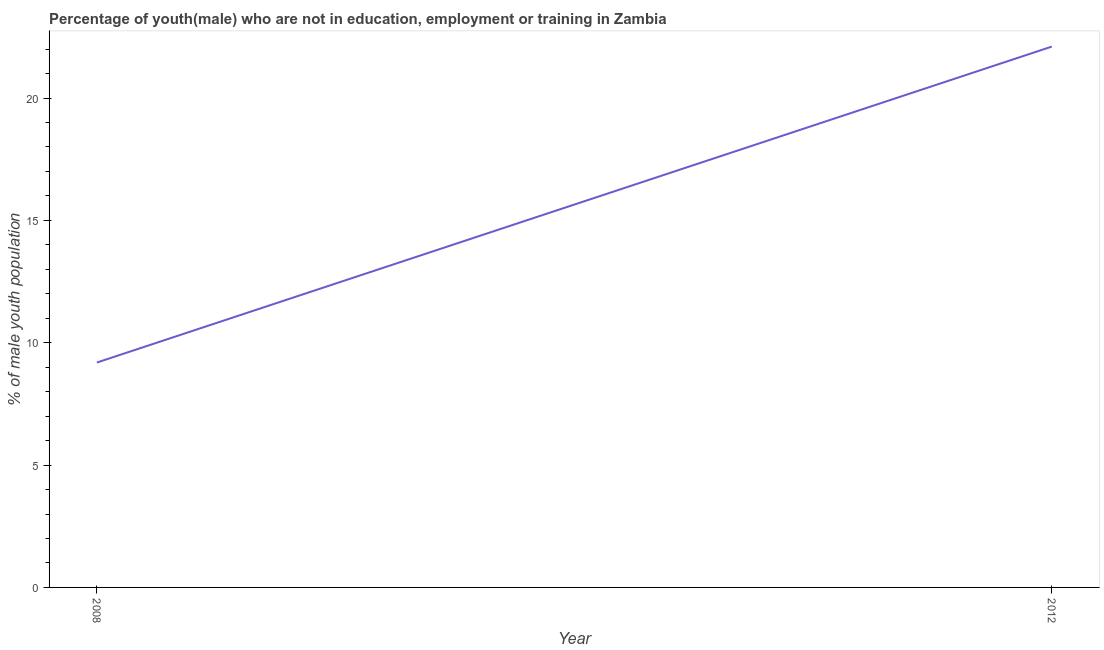What is the unemployed male youth population in 2012?
Make the answer very short. 22.1. Across all years, what is the maximum unemployed male youth population?
Provide a short and direct response. 22.1. Across all years, what is the minimum unemployed male youth population?
Your response must be concise. 9.19. What is the sum of the unemployed male youth population?
Your response must be concise. 31.29. What is the difference between the unemployed male youth population in 2008 and 2012?
Offer a very short reply. -12.91. What is the average unemployed male youth population per year?
Make the answer very short. 15.64. What is the median unemployed male youth population?
Ensure brevity in your answer.  15.64. What is the ratio of the unemployed male youth population in 2008 to that in 2012?
Provide a succinct answer. 0.42. Is the unemployed male youth population in 2008 less than that in 2012?
Provide a succinct answer. Yes. How many years are there in the graph?
Give a very brief answer. 2. What is the difference between two consecutive major ticks on the Y-axis?
Give a very brief answer. 5. Are the values on the major ticks of Y-axis written in scientific E-notation?
Give a very brief answer. No. Does the graph contain grids?
Offer a terse response. No. What is the title of the graph?
Offer a terse response. Percentage of youth(male) who are not in education, employment or training in Zambia. What is the label or title of the X-axis?
Make the answer very short. Year. What is the label or title of the Y-axis?
Ensure brevity in your answer.  % of male youth population. What is the % of male youth population in 2008?
Give a very brief answer. 9.19. What is the % of male youth population of 2012?
Your response must be concise. 22.1. What is the difference between the % of male youth population in 2008 and 2012?
Your answer should be compact. -12.91. What is the ratio of the % of male youth population in 2008 to that in 2012?
Provide a short and direct response. 0.42. 